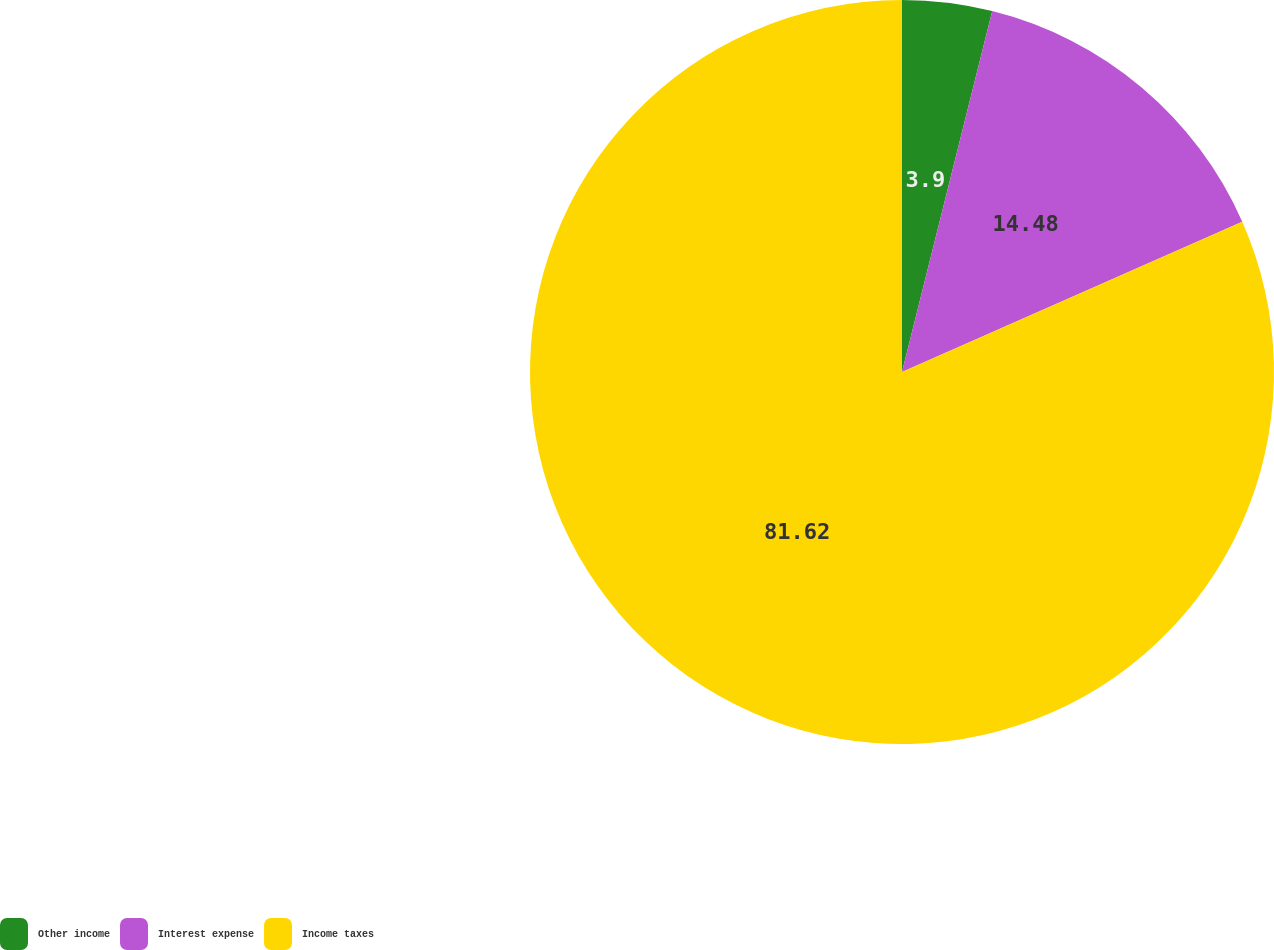Convert chart. <chart><loc_0><loc_0><loc_500><loc_500><pie_chart><fcel>Other income<fcel>Interest expense<fcel>Income taxes<nl><fcel>3.9%<fcel>14.48%<fcel>81.63%<nl></chart> 